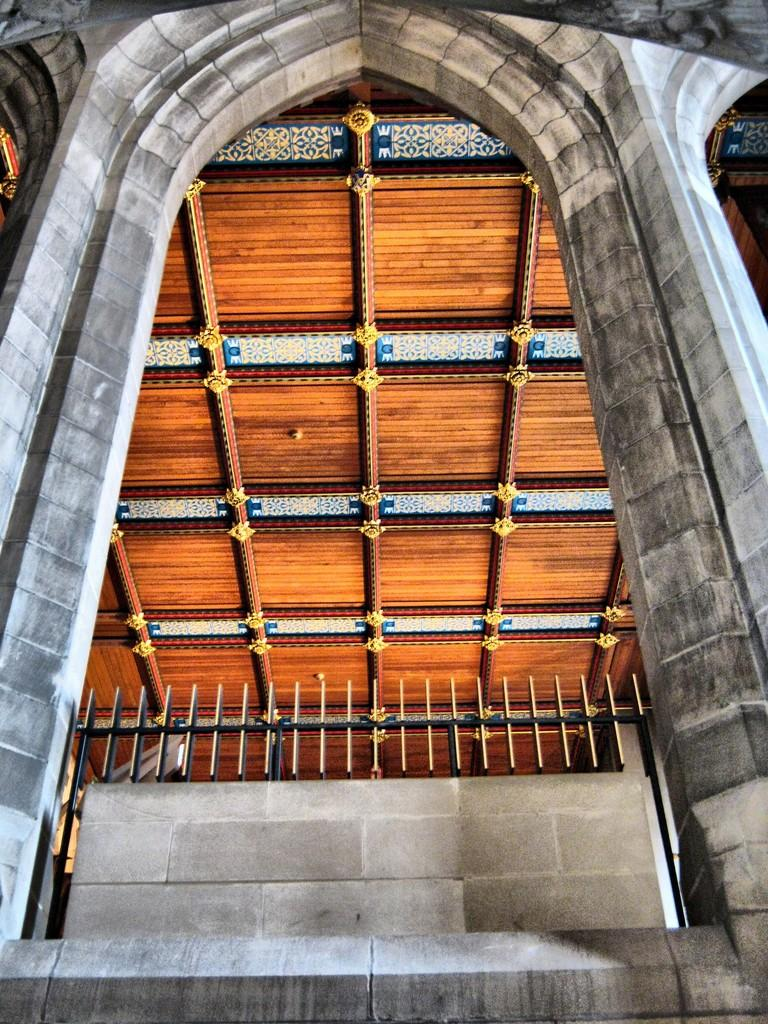What type of structure is present in the image? There is a building in the image. Can you describe the color of the building? The building is grey and cream in color. What other object can be seen in the image? There is a railing in the image. What is the color of the railing? The railing is brown in color. What part of the building is visible in the image? There is a ceiling in the image. Can you describe the color of the ceiling? The ceiling is brown, blue, and cream in color. What type of fruit is hanging from the ceiling in the image? There is no fruit hanging from the ceiling in the image; it is a building with a brown, blue, and cream ceiling. 